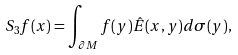Convert formula to latex. <formula><loc_0><loc_0><loc_500><loc_500>S _ { 3 } f ( x ) = \int _ { \partial M } f ( y ) \hat { E } ( x , y ) d \sigma ( y ) ,</formula> 